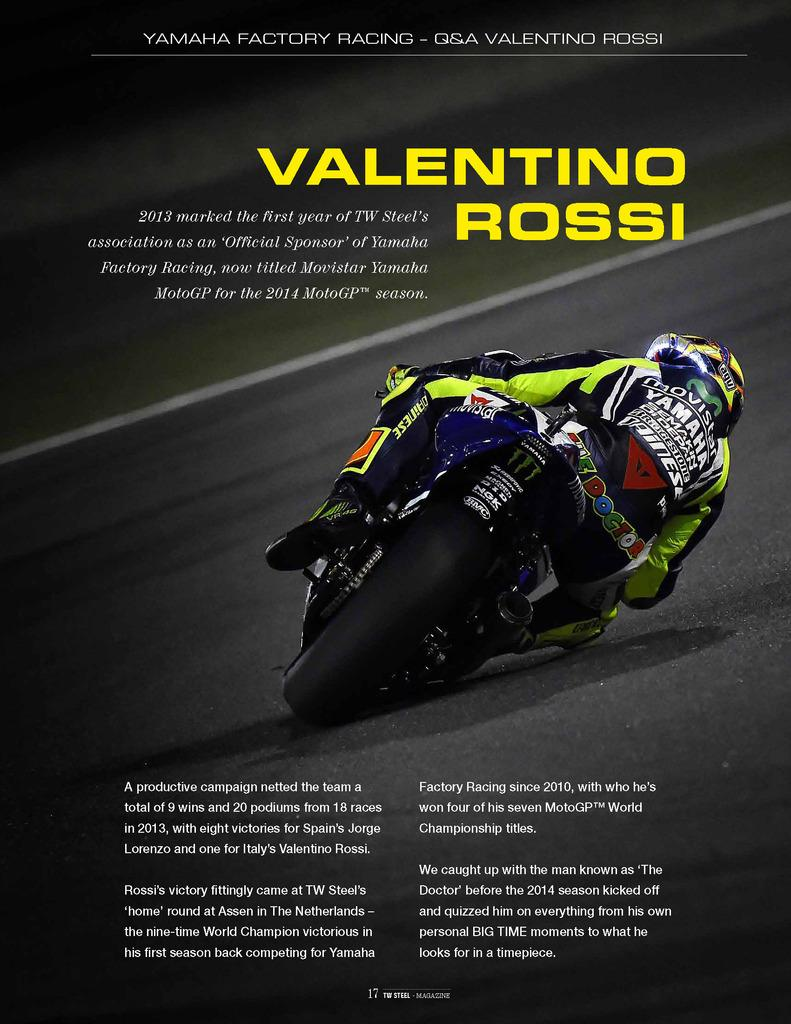What is depicted on the poster in the image? The poster features a person riding a motorcycle. Where is the text located on the poster? Text is written at the top and bottom of the poster. What is the main subject of the poster? The main subject of the poster is a person riding a motorcycle. What type of cabbage can be seen growing in the cave depicted in the image? There is no cave or cabbage present in the image; it features a poster with a person riding a motorcycle and text at the top and bottom. 